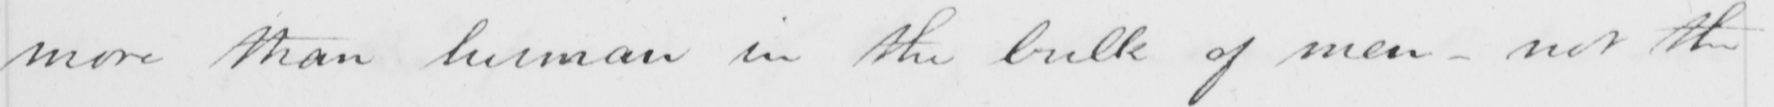Transcribe the text shown in this historical manuscript line. more than human in the bulk of men - not the 